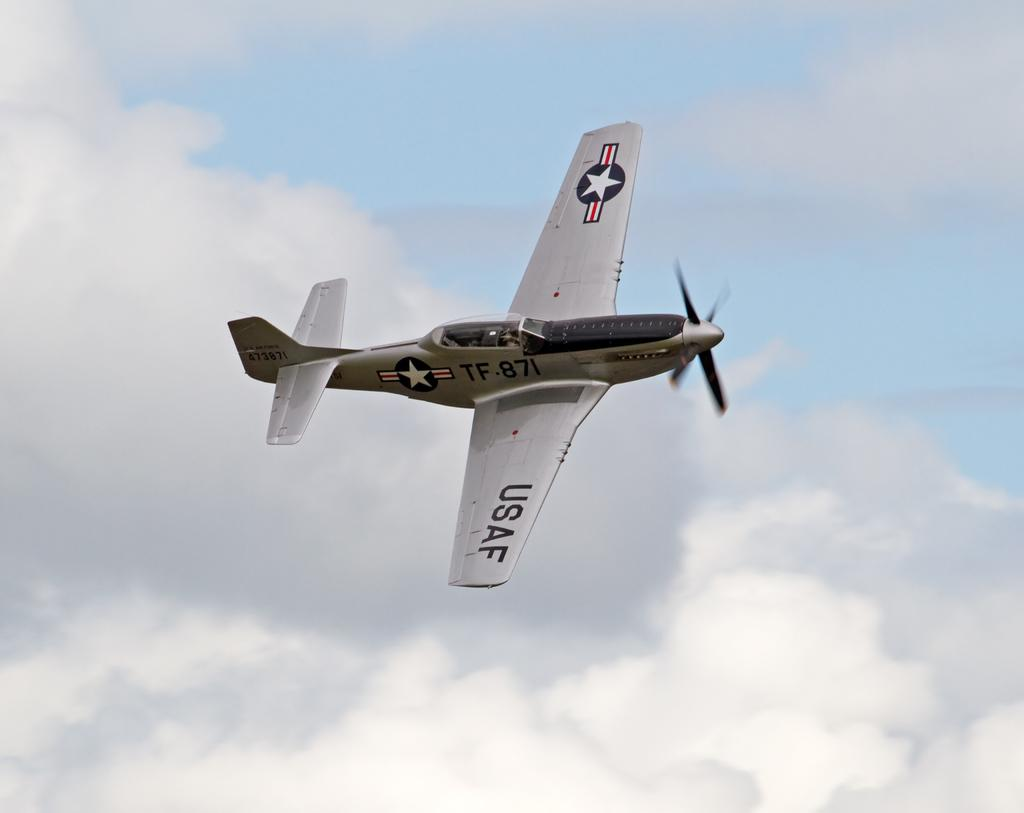What is the main subject of the image? The main subject of the image is a flying jet. Where is the jet located in the image? The jet is in the sky. What is the condition of the sky in the image? The sky is cloudy in the image. How many books can be seen on the jet in the image? There are no books present on the jet in the image. Is there any evidence of slavery in the image? There is no reference to slavery in the image. Can you see any bombs attached to the jet in the image? There are no bombs visible on the jet in the image. 